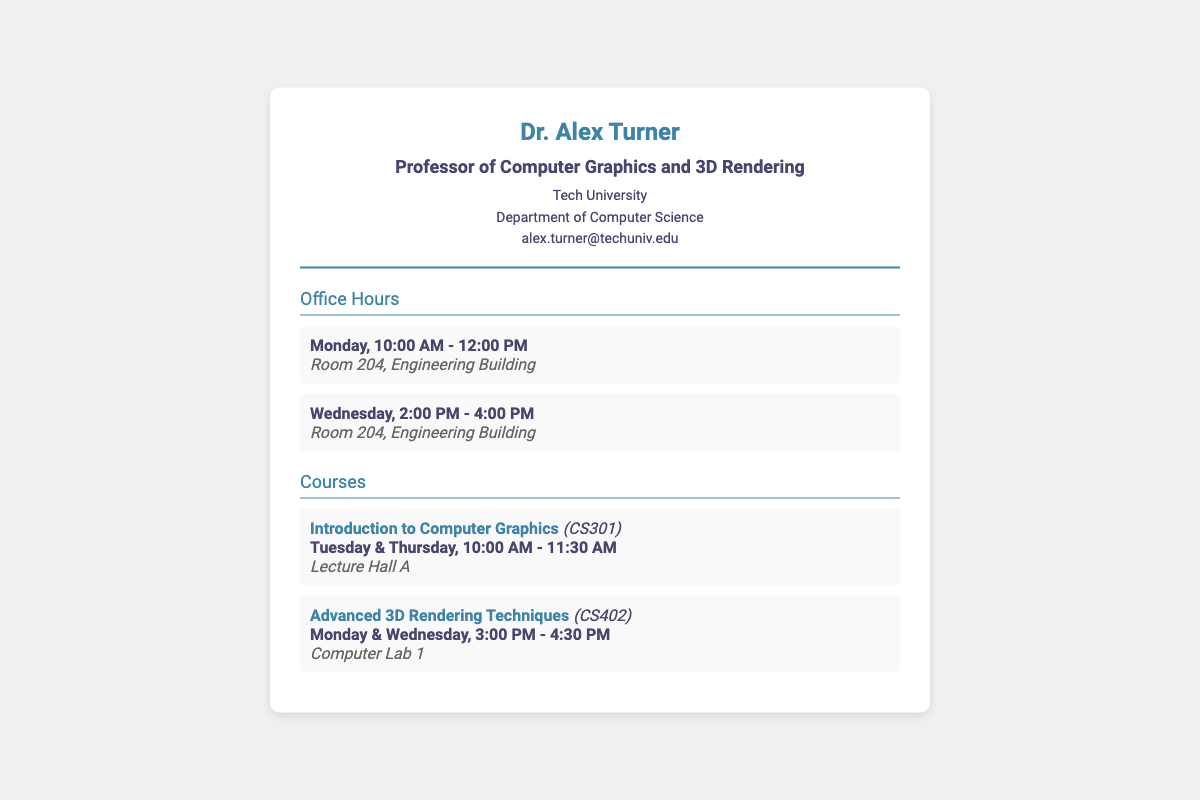What is the professor's name? The name listed at the top of the card is the professor's identity.
Answer: Dr. Alex Turner What is the course code for Advanced 3D Rendering Techniques? The course code is mentioned alongside the course title in the document's courses section.
Answer: CS402 What are the office hours on Monday? The specific times for office hours are provided in the document.
Answer: 10:00 AM - 12:00 PM Where is the lecture for Introduction to Computer Graphics held? The location for the class is indicated under each course listing.
Answer: Lecture Hall A Which department does Dr. Alex Turner belong to? The department is directly stated in the header section of the card.
Answer: Department of Computer Science How many courses are listed in the document? The number of courses detailed in the courses section provides this information.
Answer: 2 What time does the Advanced 3D Rendering Techniques class start? The starting time is mentioned in the day and time description for the course.
Answer: 3:00 PM What is the location for the office hours? The room is specifically indicated under each set of office hours in the document.
Answer: Room 204, Engineering Building On which day are the office hours held? The office hours detail this information in their respective entries.
Answer: Monday and Wednesday 